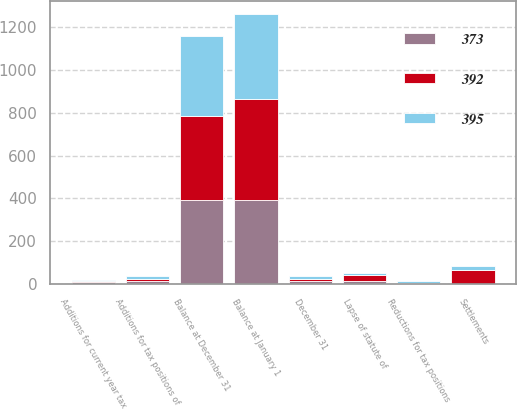Convert chart. <chart><loc_0><loc_0><loc_500><loc_500><stacked_bar_chart><ecel><fcel>December 31<fcel>Balance at January 1<fcel>Additions for current year tax<fcel>Additions for tax positions of<fcel>Reductions for tax positions<fcel>Settlements<fcel>Lapse of statute of<fcel>Balance at December 31<nl><fcel>395<fcel>12<fcel>395<fcel>6<fcel>12<fcel>7<fcel>19<fcel>7<fcel>373<nl><fcel>373<fcel>12<fcel>392<fcel>8<fcel>14<fcel>2<fcel>2<fcel>12<fcel>395<nl><fcel>392<fcel>12<fcel>475<fcel>7<fcel>10<fcel>3<fcel>65<fcel>32<fcel>392<nl></chart> 